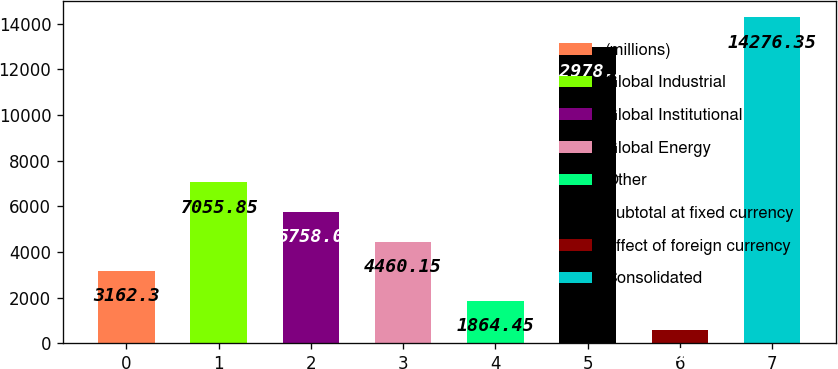Convert chart to OTSL. <chart><loc_0><loc_0><loc_500><loc_500><bar_chart><fcel>(millions)<fcel>Global Industrial<fcel>Global Institutional<fcel>Global Energy<fcel>Other<fcel>Subtotal at fixed currency<fcel>Effect of foreign currency<fcel>Consolidated<nl><fcel>3162.3<fcel>7055.85<fcel>5758<fcel>4460.15<fcel>1864.45<fcel>12978.5<fcel>566.6<fcel>14276.4<nl></chart> 